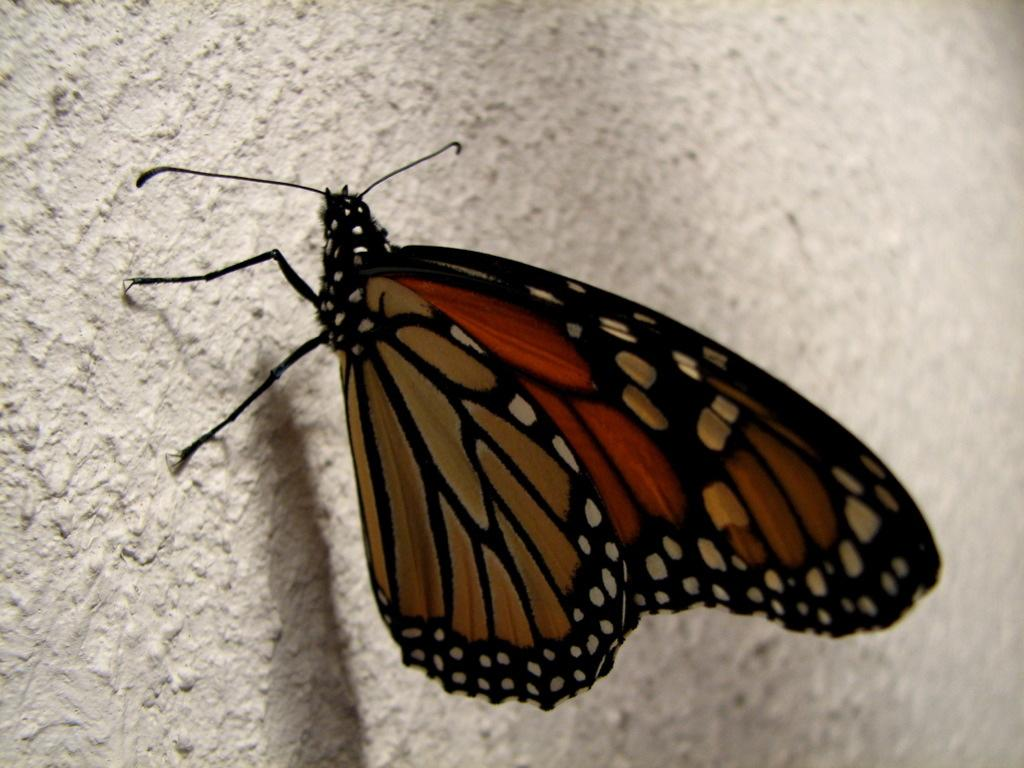What is the main subject of the image? There is a butterfly in the image. Where is the butterfly located in the image? The butterfly is on a surface. What type of basketball is the butterfly playing in the image? There is no basketball present in the image. The image features a butterfly on a surface. 